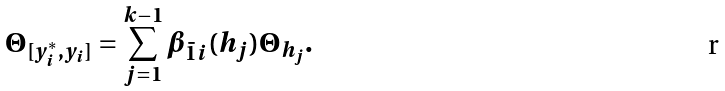Convert formula to latex. <formula><loc_0><loc_0><loc_500><loc_500>\Theta _ { [ y ^ { * } _ { i } , y _ { i } ] } = \sum _ { j = 1 } ^ { k - 1 } \beta _ { \bar { 1 } i } ( h _ { j } ) \Theta _ { h _ { j } } .</formula> 